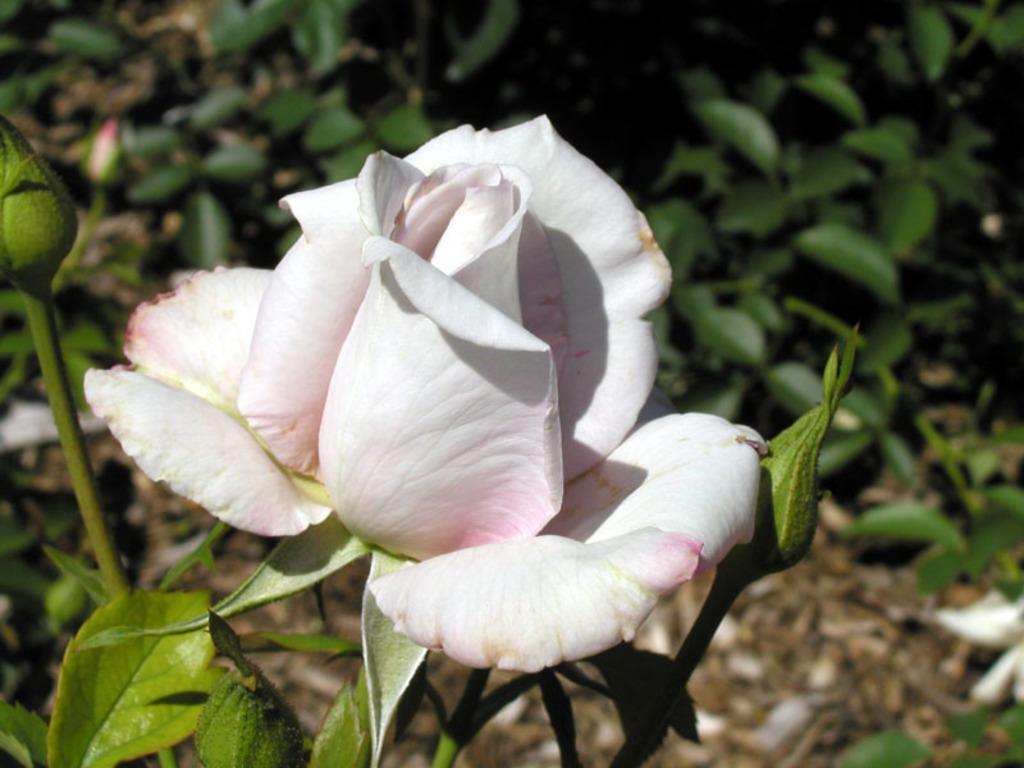Describe this image in one or two sentences. In the center of the image we can see a rose flower and buds. In the background of the image we can see the plants and ground. 